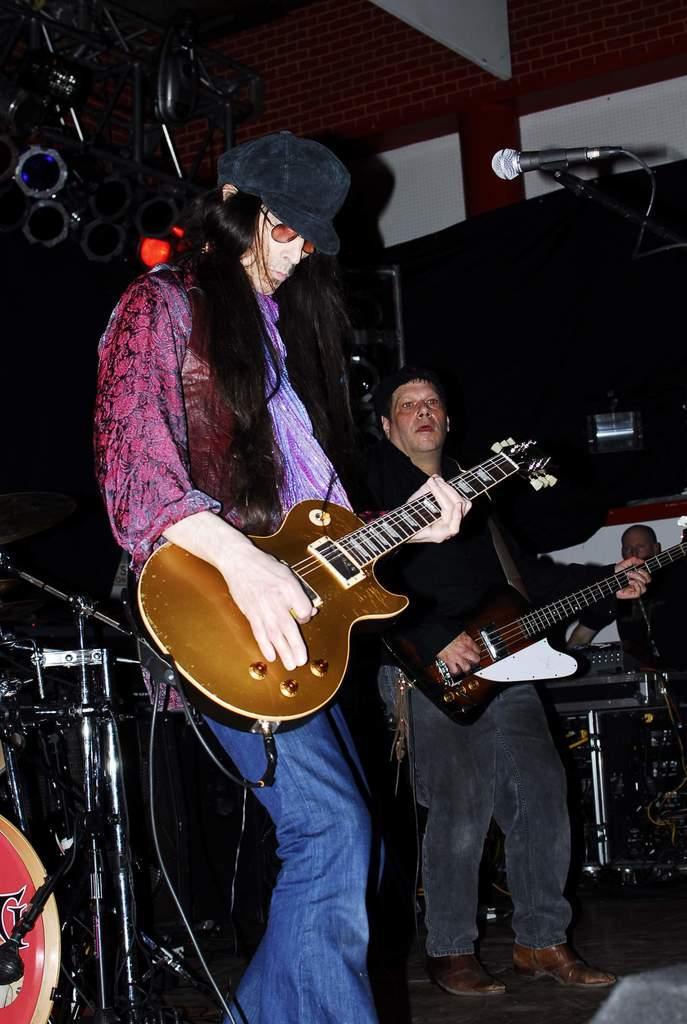Describe this image in one or two sentences. this picture shows two men standing and playing guitar and we see a man standing on the side 